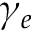Convert formula to latex. <formula><loc_0><loc_0><loc_500><loc_500>\gamma _ { e }</formula> 